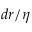Convert formula to latex. <formula><loc_0><loc_0><loc_500><loc_500>d r / \eta</formula> 